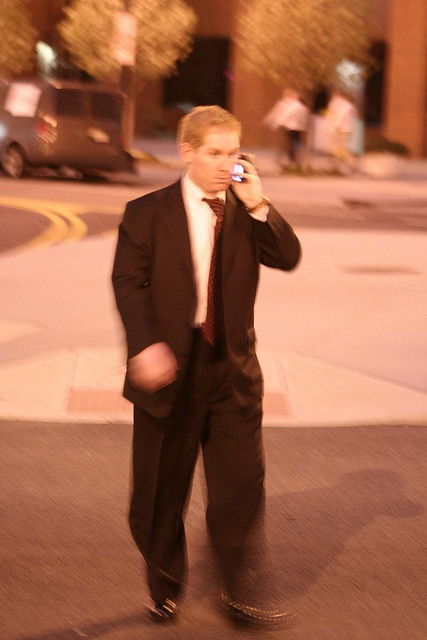Describe the objects in this image and their specific colors. I can see people in brown, black, maroon, salmon, and tan tones, car in brown and maroon tones, people in brown, salmon, and maroon tones, people in brown and salmon tones, and tie in brown, maroon, and black tones in this image. 